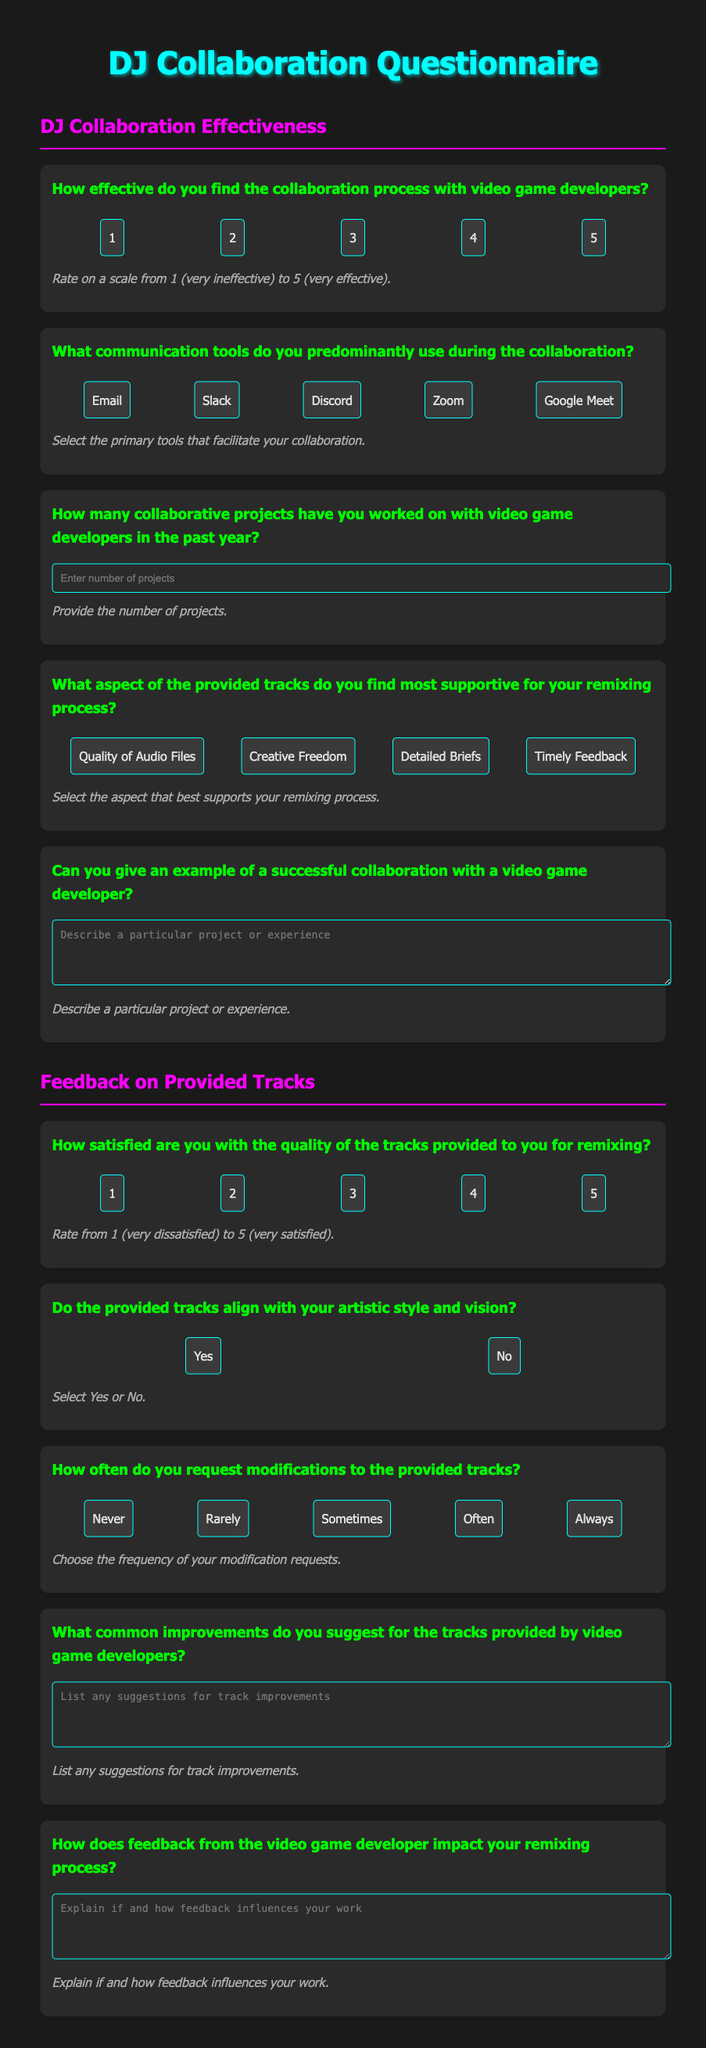What is the title of the document? The title is prominently displayed at the top of the document and indicates the purpose.
Answer: DJ Collaboration Questionnaire How many rating options are provided for the effectiveness of collaboration? The document lists the rating options, which typically range to five points.
Answer: 5 What is the highest rating for the effectiveness of collaboration? The scale goes from 1 to 5, indicating the maximum rating.
Answer: 5 What communication tool is not listed in the options? The document provides a list of commonly used communication tools, but does not include a specific option.
Answer: Phone What aspect of provided tracks is highlighted as supportive for remixing? The questionnaire specifies several aspects that can aid the remixing process for DJs.
Answer: Quality of Audio Files What rating do you give for satisfaction with the quality of tracks? The document provides a scale to assess satisfaction levels regarding the quality of tracks.
Answer: 1 to 5 How often do DJs request modifications? The questionnaire encourages DJs to choose a frequency for their modification requests from a provided list.
Answer: Often What type of feedback is requested regarding track improvements? The document asks for suggestions on improvements that could be beneficial for the provided tracks.
Answer: List any suggestions for track improvements What follow-up question addresses the impact of feedback? The document contains a specific question that asks about the influence of feedback from developers on the remixing process.
Answer: Explain if and how feedback influences your work 